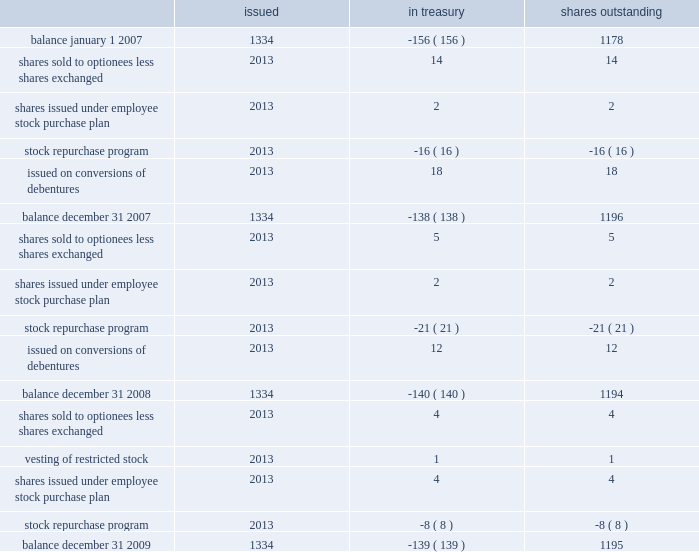Part ii , item 8 schlumberger limited and subsidiaries shares of common stock ( stated in millions ) issued in treasury shares outstanding .
See the notes to consolidated financial statements .
How many shares were repurchased in this period? 
Computations: (((16 + 21) + 8) * 1000000)
Answer: 45000000.0. 